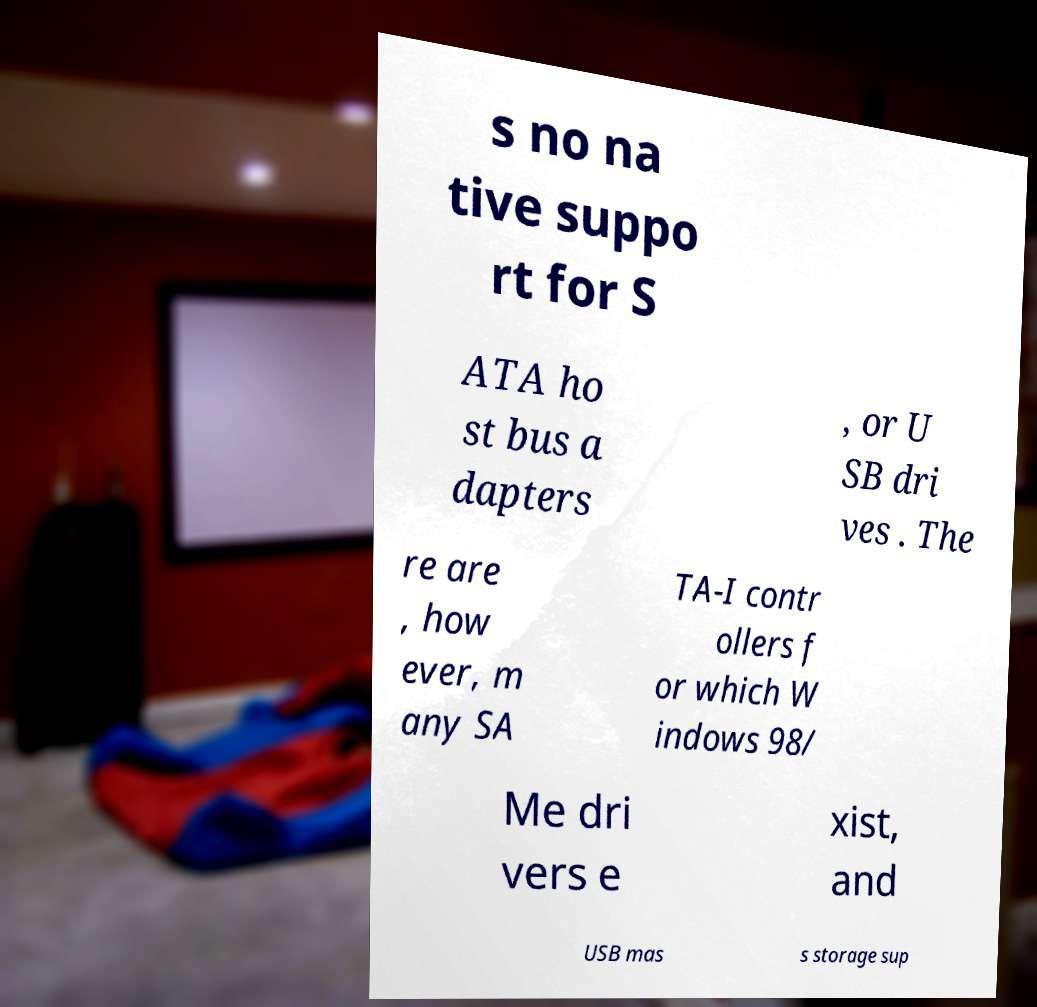There's text embedded in this image that I need extracted. Can you transcribe it verbatim? s no na tive suppo rt for S ATA ho st bus a dapters , or U SB dri ves . The re are , how ever, m any SA TA-I contr ollers f or which W indows 98/ Me dri vers e xist, and USB mas s storage sup 